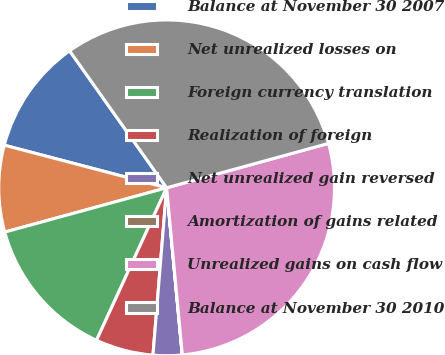Convert chart. <chart><loc_0><loc_0><loc_500><loc_500><pie_chart><fcel>Balance at November 30 2007<fcel>Net unrealized losses on<fcel>Foreign currency translation<fcel>Realization of foreign<fcel>Net unrealized gain reversed<fcel>Amortization of gains related<fcel>Unrealized gains on cash flow<fcel>Balance at November 30 2010<nl><fcel>11.11%<fcel>8.34%<fcel>13.89%<fcel>5.56%<fcel>2.78%<fcel>0.01%<fcel>27.77%<fcel>30.55%<nl></chart> 